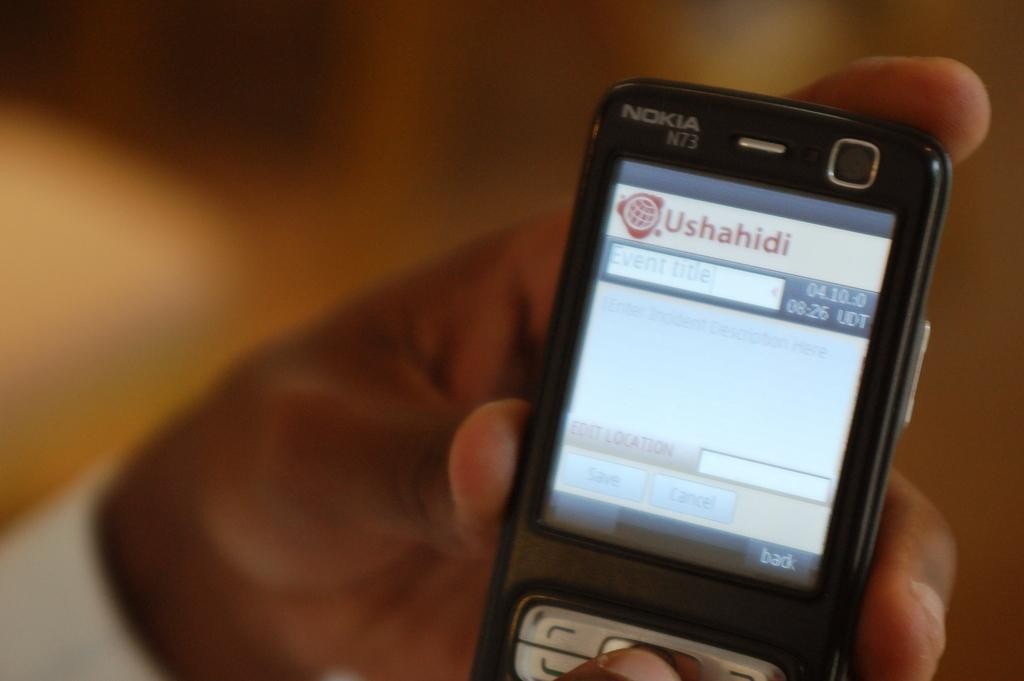Provide a one-sentence caption for the provided image. A man holding a phone opened to the Ushahidi app. 